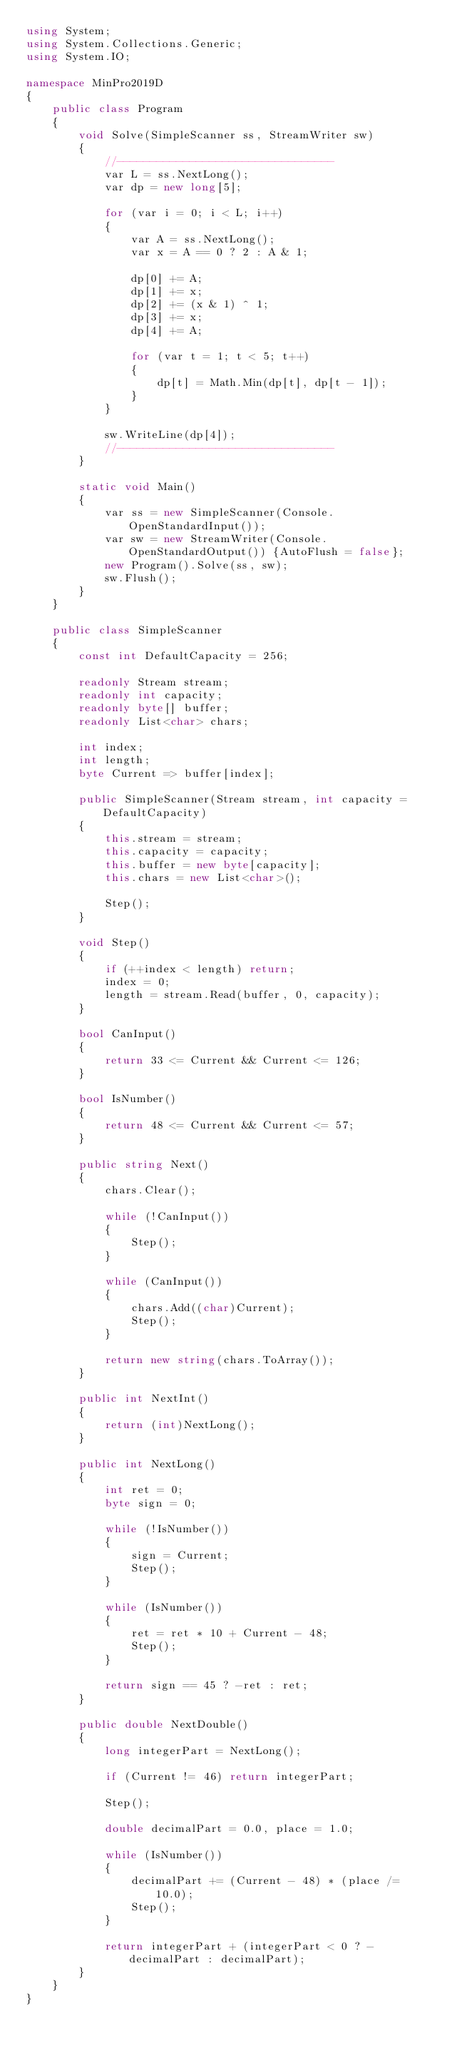Convert code to text. <code><loc_0><loc_0><loc_500><loc_500><_C#_>using System;
using System.Collections.Generic;
using System.IO;

namespace MinPro2019D
{
    public class Program
    {
        void Solve(SimpleScanner ss, StreamWriter sw)
        {
            //---------------------------------
            var L = ss.NextLong();
            var dp = new long[5];

            for (var i = 0; i < L; i++)
            {
                var A = ss.NextLong();
                var x = A == 0 ? 2 : A & 1;

                dp[0] += A;
                dp[1] += x;
                dp[2] += (x & 1) ^ 1;
                dp[3] += x;
                dp[4] += A;

                for (var t = 1; t < 5; t++)
                {
                    dp[t] = Math.Min(dp[t], dp[t - 1]);
                }
            }

            sw.WriteLine(dp[4]);
            //---------------------------------
        }

        static void Main()
        {
            var ss = new SimpleScanner(Console.OpenStandardInput());
            var sw = new StreamWriter(Console.OpenStandardOutput()) {AutoFlush = false};
            new Program().Solve(ss, sw);
            sw.Flush();
        }
    }

    public class SimpleScanner
    {
        const int DefaultCapacity = 256;

        readonly Stream stream;
        readonly int capacity;
        readonly byte[] buffer;
        readonly List<char> chars;

        int index;
        int length;
        byte Current => buffer[index];

        public SimpleScanner(Stream stream, int capacity = DefaultCapacity)
        {
            this.stream = stream;
            this.capacity = capacity;
            this.buffer = new byte[capacity];
            this.chars = new List<char>();

            Step();
        }

        void Step()
        {
            if (++index < length) return;
            index = 0;
            length = stream.Read(buffer, 0, capacity);
        }

        bool CanInput()
        {
            return 33 <= Current && Current <= 126;
        }

        bool IsNumber()
        {
            return 48 <= Current && Current <= 57;
        }

        public string Next()
        {
            chars.Clear();

            while (!CanInput())
            {
                Step();
            }

            while (CanInput())
            {
                chars.Add((char)Current);
                Step();
            }

            return new string(chars.ToArray());
        }

        public int NextInt()
        {
            return (int)NextLong();
        }

        public int NextLong()
        {
            int ret = 0;
            byte sign = 0;

            while (!IsNumber())
            {
                sign = Current;
                Step();
            }

            while (IsNumber())
            {
                ret = ret * 10 + Current - 48;
                Step();
            }

            return sign == 45 ? -ret : ret;
        }

        public double NextDouble()
        {
            long integerPart = NextLong();

            if (Current != 46) return integerPart;

            Step();

            double decimalPart = 0.0, place = 1.0;

            while (IsNumber())
            {
                decimalPart += (Current - 48) * (place /= 10.0);
                Step();
            }

            return integerPart + (integerPart < 0 ? -decimalPart : decimalPart);
        }
    }
}
</code> 